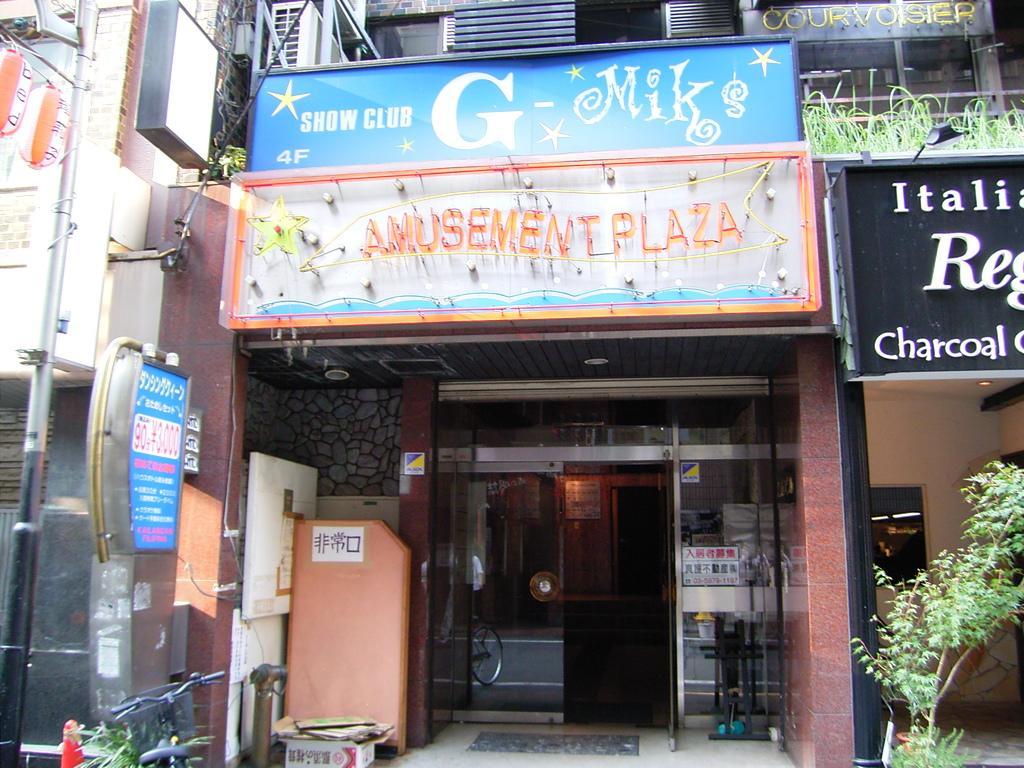Can you describe this image briefly? In this picture we can see glass door. On the top there is a building. Here we can see banners, posters and the shop name. On the bottom left corner we can see electric pole and cotton boxes. On the right there is a plant. Here we can see grass which is near to the light. 